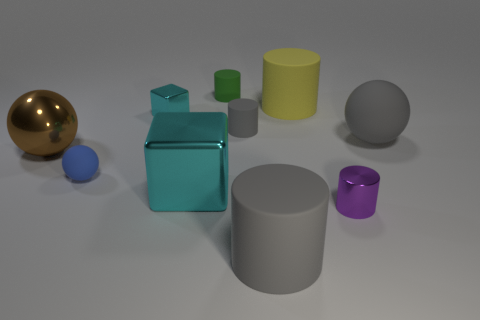Is there a large metallic thing of the same shape as the small cyan object? yes 